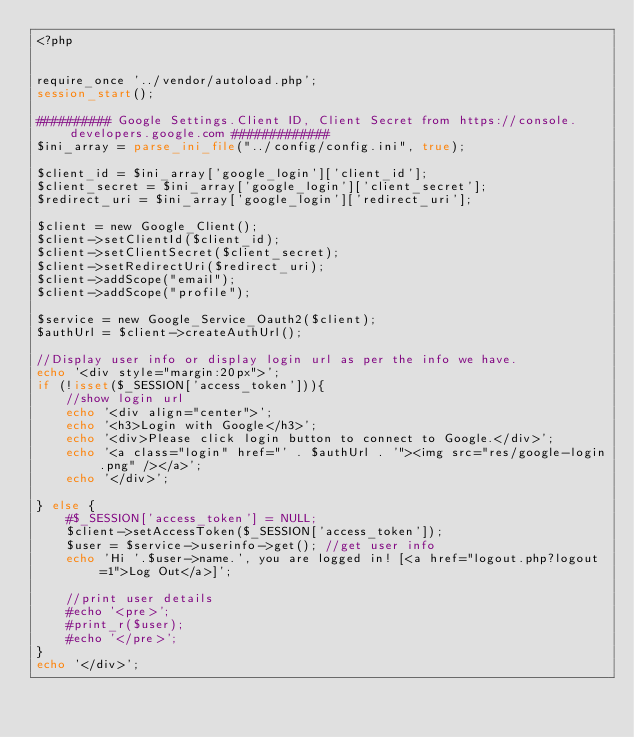Convert code to text. <code><loc_0><loc_0><loc_500><loc_500><_PHP_><?php


require_once '../vendor/autoload.php';
session_start();

########## Google Settings.Client ID, Client Secret from https://console.developers.google.com #############
$ini_array = parse_ini_file("../config/config.ini", true);

$client_id = $ini_array['google_login']['client_id'];
$client_secret = $ini_array['google_login']['client_secret'];
$redirect_uri = $ini_array['google_login']['redirect_uri'];

$client = new Google_Client();
$client->setClientId($client_id);
$client->setClientSecret($client_secret);
$client->setRedirectUri($redirect_uri);
$client->addScope("email");
$client->addScope("profile");

$service = new Google_Service_Oauth2($client);
$authUrl = $client->createAuthUrl();

//Display user info or display login url as per the info we have.
echo '<div style="margin:20px">';
if (!isset($_SESSION['access_token'])){ 
    //show login url
    echo '<div align="center">';
    echo '<h3>Login with Google</h3>';
    echo '<div>Please click login button to connect to Google.</div>';
    echo '<a class="login" href="' . $authUrl . '"><img src="res/google-login.png" /></a>';
    echo '</div>';
    
} else {
	#$_SESSION['access_token'] = NULL;
	$client->setAccessToken($_SESSION['access_token']);
    $user = $service->userinfo->get(); //get user info 
	echo 'Hi '.$user->name.', you are logged in! [<a href="logout.php?logout=1">Log Out</a>]';
    
    //print user details
    #echo '<pre>';
    #print_r($user);
    #echo '</pre>';
}
echo '</div>';
</code> 